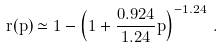Convert formula to latex. <formula><loc_0><loc_0><loc_500><loc_500>r ( p ) \simeq 1 - \left ( 1 + \frac { 0 . 9 2 4 } { 1 . 2 4 } p \right ) ^ { - 1 . 2 4 } \, .</formula> 